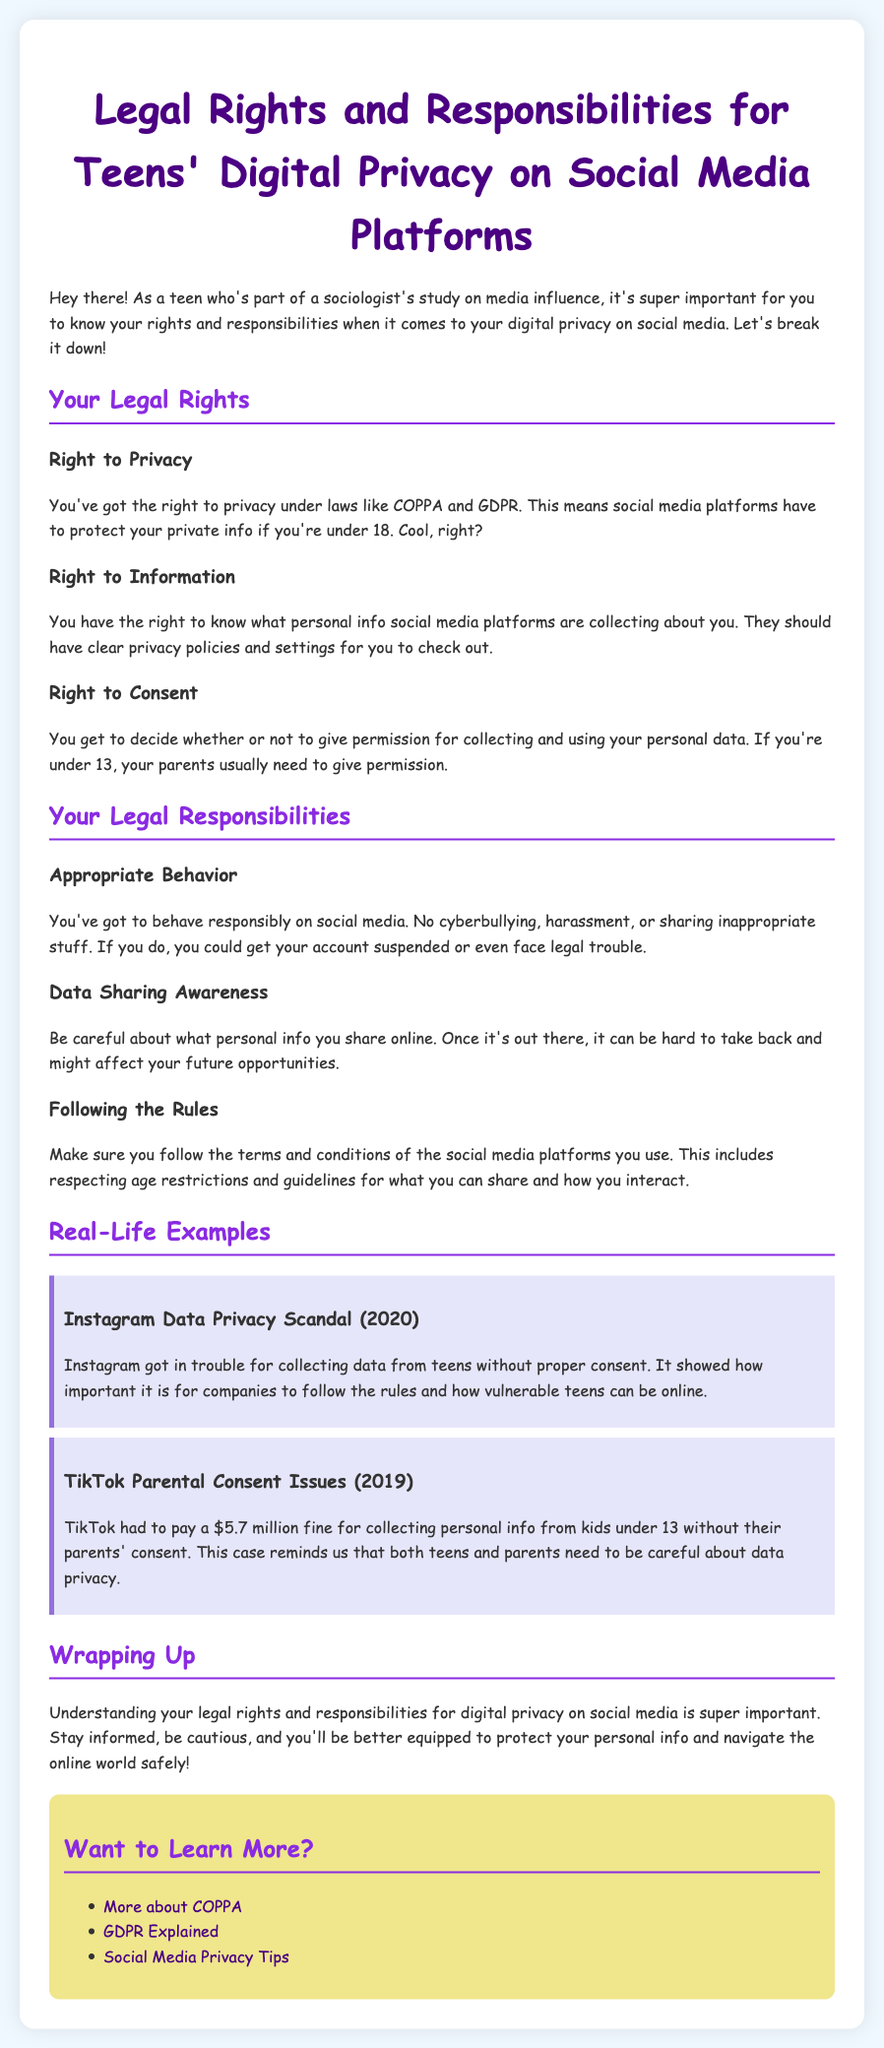what is COPPA? COPPA stands for the Children's Online Privacy Protection Act, which protects the privacy of children under 13 online.
Answer: Children's Online Privacy Protection Act what is GDPR? GDPR stands for the General Data Protection Regulation, which governs data protection and privacy in the European Union.
Answer: General Data Protection Regulation what happens if you violate social media rules? If you violate social media rules, you could get your account suspended or even face legal trouble.
Answer: Account suspended or legal trouble what was the fine TikTok had to pay? TikTok had to pay a $5.7 million fine for collecting personal info from kids under 13 without proper consent.
Answer: $5.7 million what should social media platforms provide regarding personal data? Social media platforms should have clear privacy policies and settings for users to check out.
Answer: Clear privacy policies and settings what is a key responsibility for teens on social media? Teens must behave responsibly on social media and avoid cyberbullying and harassment.
Answer: Behave responsibly how are teens protected under privacy laws? Teens are protected under laws like COPPA and GDPR that require social media platforms to protect their private info if they are under 18.
Answer: Protected under COPPA and GDPR what do you need if you are under 13 and want to use social media? If you are under 13, your parents usually need to give permission.
Answer: Parent permission what should you be careful about sharing online? You should be careful about what personal info you share online as it can affect your future opportunities.
Answer: Personal info what is the purpose of the document? The purpose of the document is to inform teens about their legal rights and responsibilities regarding digital privacy on social media.
Answer: Inform about legal rights and responsibilities 